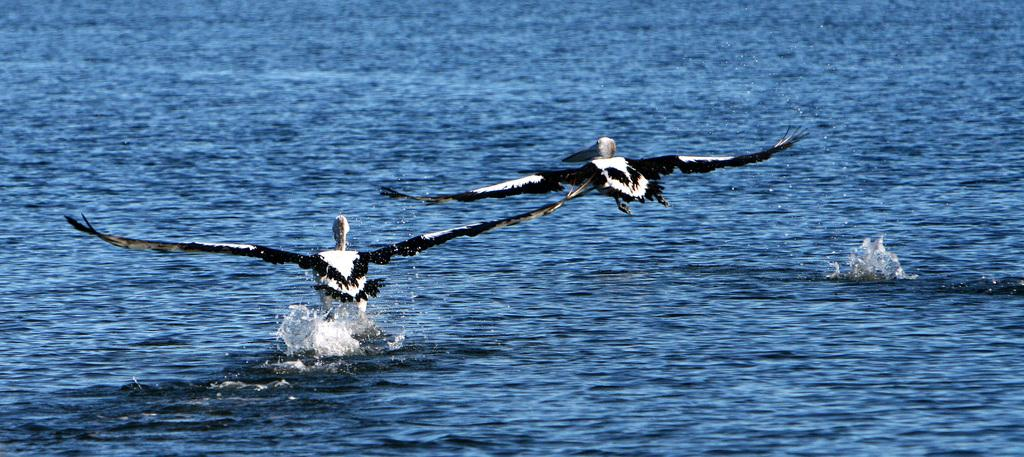How many birds are visible in the image? There are two birds in the image. What are the birds doing in the image? The birds are flying above the water surface. Can you hear the snake in the image? There is no snake present in the image, so it cannot be heard. 